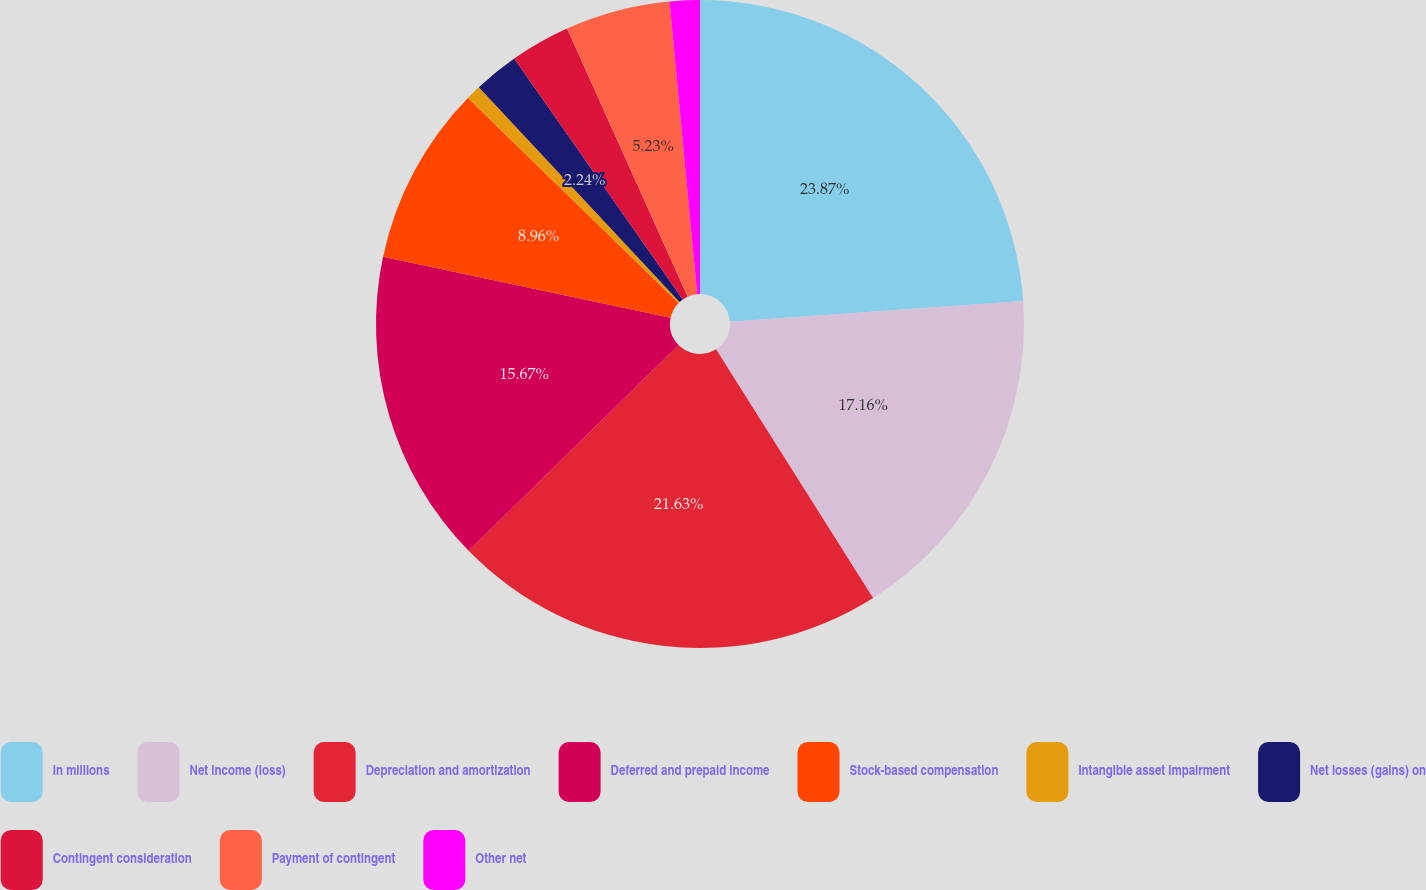<chart> <loc_0><loc_0><loc_500><loc_500><pie_chart><fcel>in millions<fcel>Net income (loss)<fcel>Depreciation and amortization<fcel>Deferred and prepaid income<fcel>Stock-based compensation<fcel>Intangible asset impairment<fcel>Net losses (gains) on<fcel>Contingent consideration<fcel>Payment of contingent<fcel>Other net<nl><fcel>23.87%<fcel>17.16%<fcel>21.63%<fcel>15.67%<fcel>8.96%<fcel>0.75%<fcel>2.24%<fcel>2.99%<fcel>5.23%<fcel>1.5%<nl></chart> 